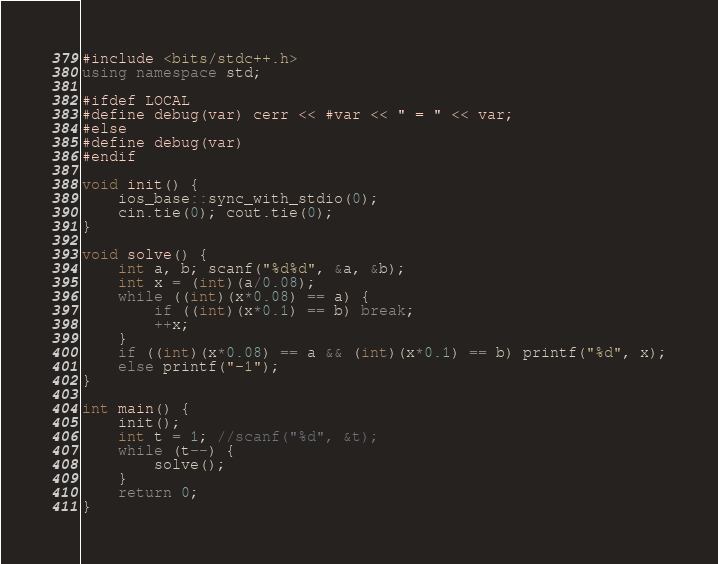Convert code to text. <code><loc_0><loc_0><loc_500><loc_500><_C++_>#include <bits/stdc++.h>
using namespace std;

#ifdef LOCAL
#define debug(var) cerr << #var << " = " << var;
#else
#define debug(var)
#endif

void init() {
	ios_base::sync_with_stdio(0);
	cin.tie(0); cout.tie(0);
}

void solve() {
	int a, b; scanf("%d%d", &a, &b);
	int x = (int)(a/0.08);
	while ((int)(x*0.08) == a) {
		if ((int)(x*0.1) == b) break;
		++x;
	}
	if ((int)(x*0.08) == a && (int)(x*0.1) == b) printf("%d", x);
	else printf("-1");
}

int main() {
	init();
	int t = 1; //scanf("%d", &t);
	while (t--) {
		solve();
	}
	return 0;
}
</code> 